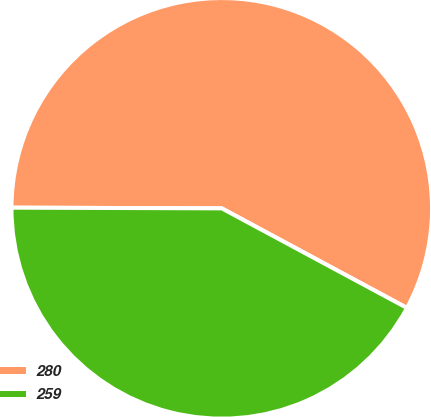Convert chart to OTSL. <chart><loc_0><loc_0><loc_500><loc_500><pie_chart><fcel>280<fcel>259<nl><fcel>57.8%<fcel>42.2%<nl></chart> 